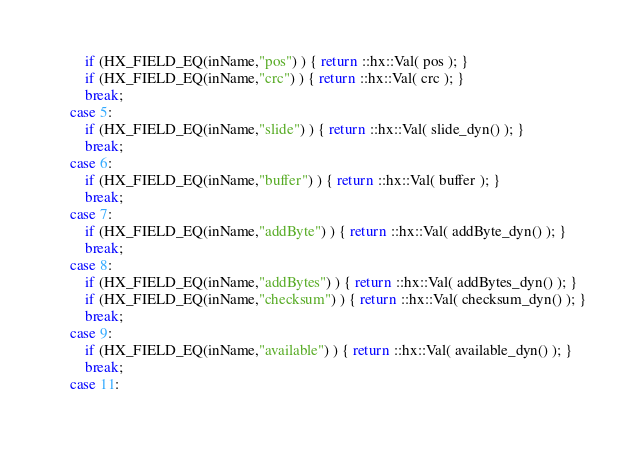<code> <loc_0><loc_0><loc_500><loc_500><_C++_>		if (HX_FIELD_EQ(inName,"pos") ) { return ::hx::Val( pos ); }
		if (HX_FIELD_EQ(inName,"crc") ) { return ::hx::Val( crc ); }
		break;
	case 5:
		if (HX_FIELD_EQ(inName,"slide") ) { return ::hx::Val( slide_dyn() ); }
		break;
	case 6:
		if (HX_FIELD_EQ(inName,"buffer") ) { return ::hx::Val( buffer ); }
		break;
	case 7:
		if (HX_FIELD_EQ(inName,"addByte") ) { return ::hx::Val( addByte_dyn() ); }
		break;
	case 8:
		if (HX_FIELD_EQ(inName,"addBytes") ) { return ::hx::Val( addBytes_dyn() ); }
		if (HX_FIELD_EQ(inName,"checksum") ) { return ::hx::Val( checksum_dyn() ); }
		break;
	case 9:
		if (HX_FIELD_EQ(inName,"available") ) { return ::hx::Val( available_dyn() ); }
		break;
	case 11:</code> 